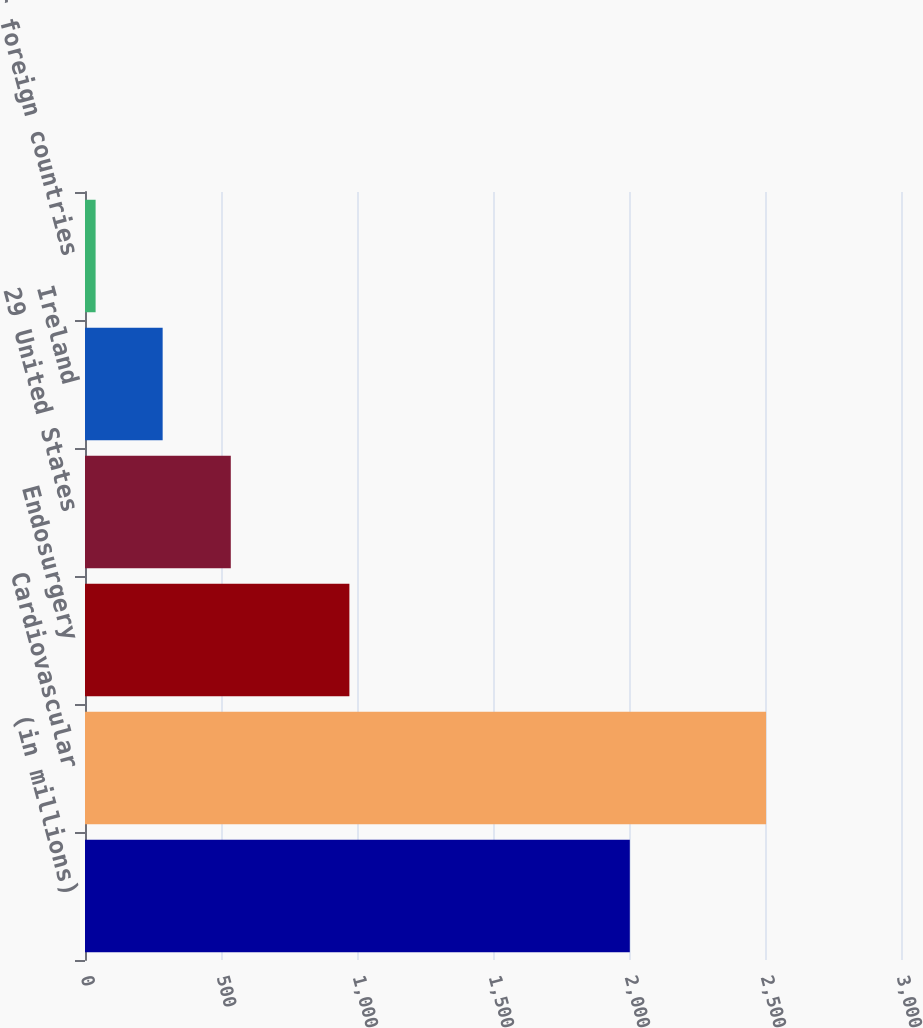Convert chart. <chart><loc_0><loc_0><loc_500><loc_500><bar_chart><fcel>(in millions)<fcel>Cardiovascular<fcel>Endosurgery<fcel>29 United States<fcel>Ireland<fcel>3004 Other foreign countries<nl><fcel>2003<fcel>2504<fcel>972<fcel>536<fcel>285.5<fcel>39<nl></chart> 